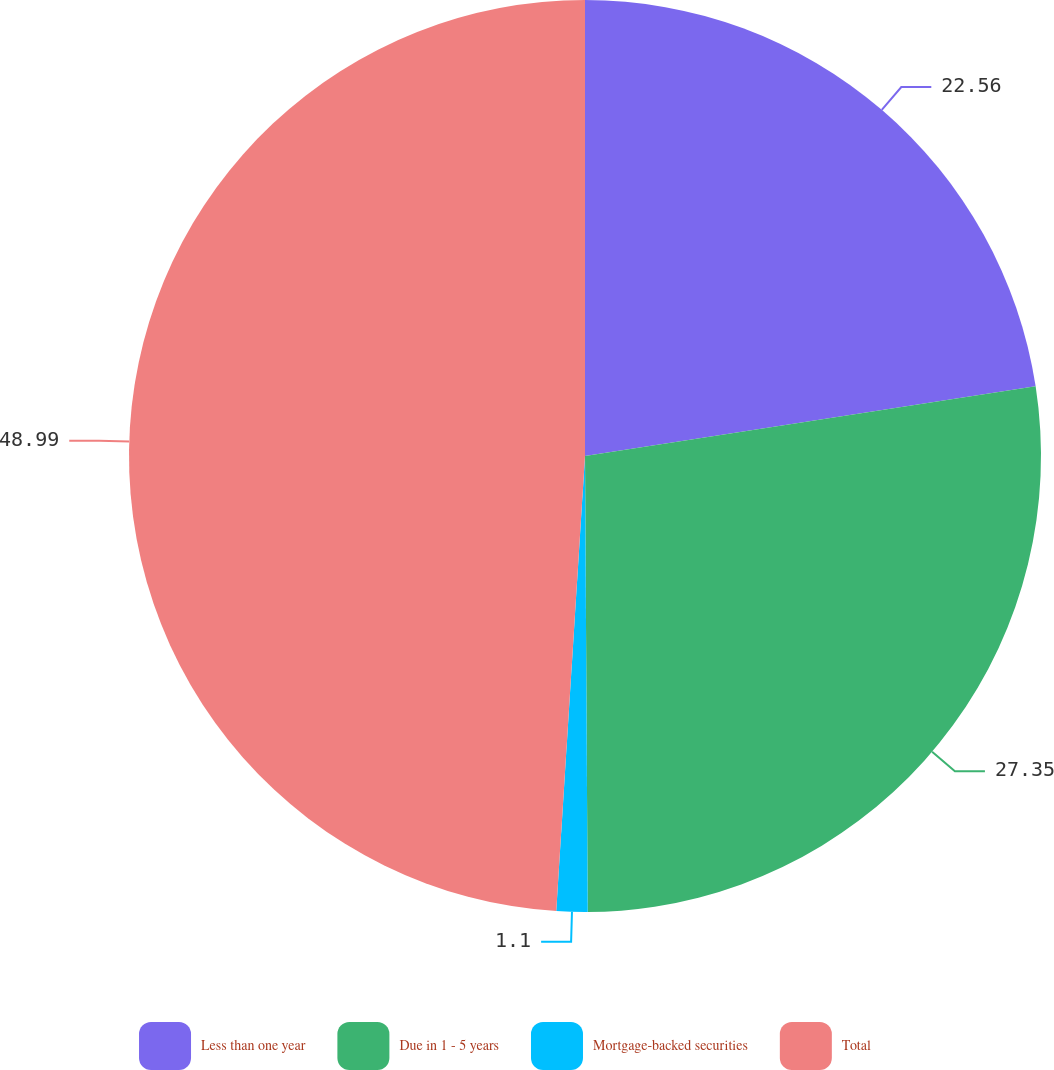<chart> <loc_0><loc_0><loc_500><loc_500><pie_chart><fcel>Less than one year<fcel>Due in 1 - 5 years<fcel>Mortgage-backed securities<fcel>Total<nl><fcel>22.56%<fcel>27.35%<fcel>1.1%<fcel>49.0%<nl></chart> 